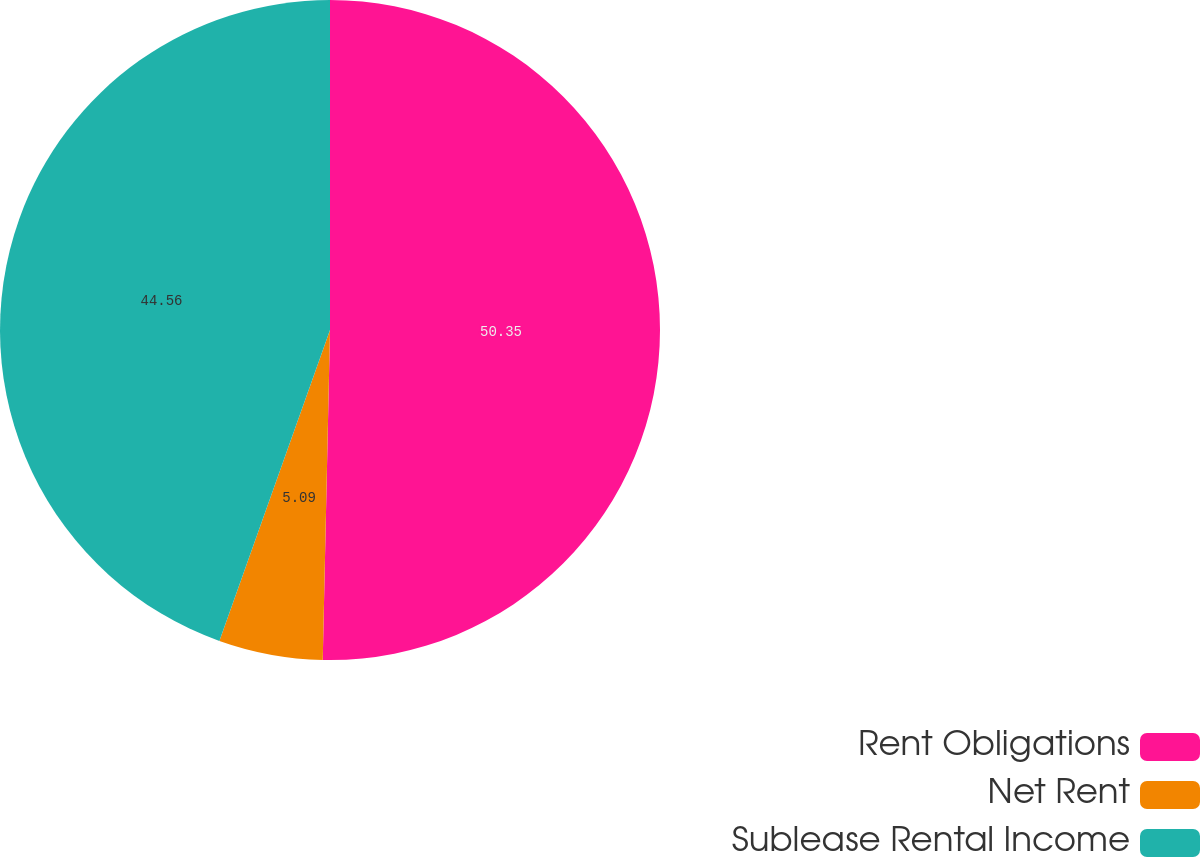<chart> <loc_0><loc_0><loc_500><loc_500><pie_chart><fcel>Rent Obligations<fcel>Net Rent<fcel>Sublease Rental Income<nl><fcel>50.35%<fcel>5.09%<fcel>44.56%<nl></chart> 